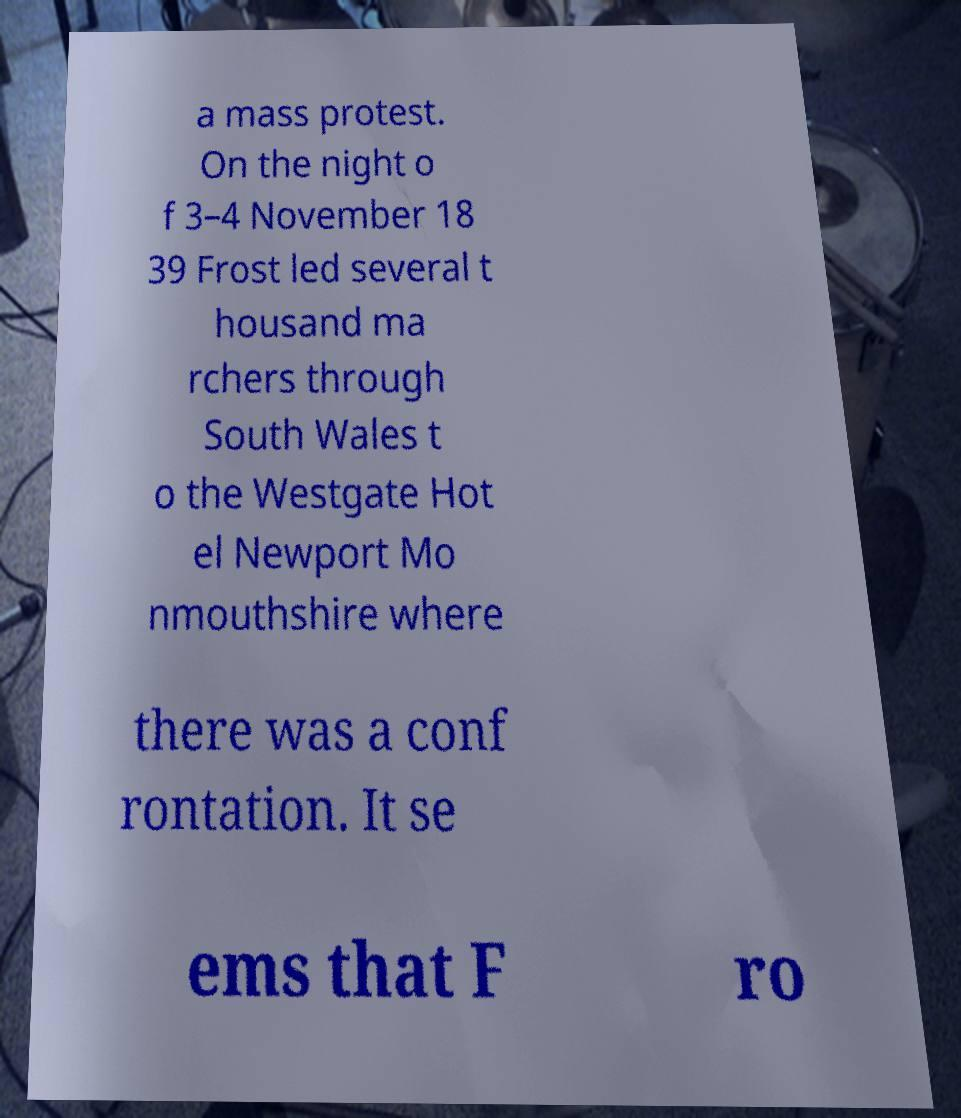Can you read and provide the text displayed in the image?This photo seems to have some interesting text. Can you extract and type it out for me? a mass protest. On the night o f 3–4 November 18 39 Frost led several t housand ma rchers through South Wales t o the Westgate Hot el Newport Mo nmouthshire where there was a conf rontation. It se ems that F ro 